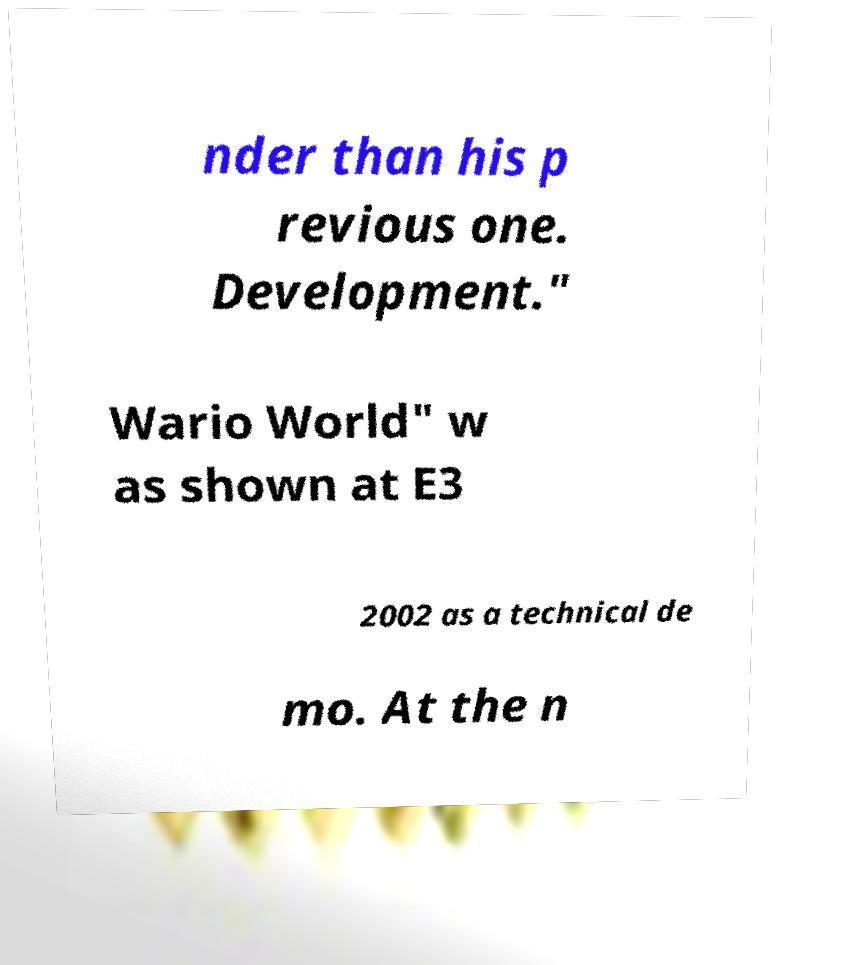Could you assist in decoding the text presented in this image and type it out clearly? nder than his p revious one. Development." Wario World" w as shown at E3 2002 as a technical de mo. At the n 